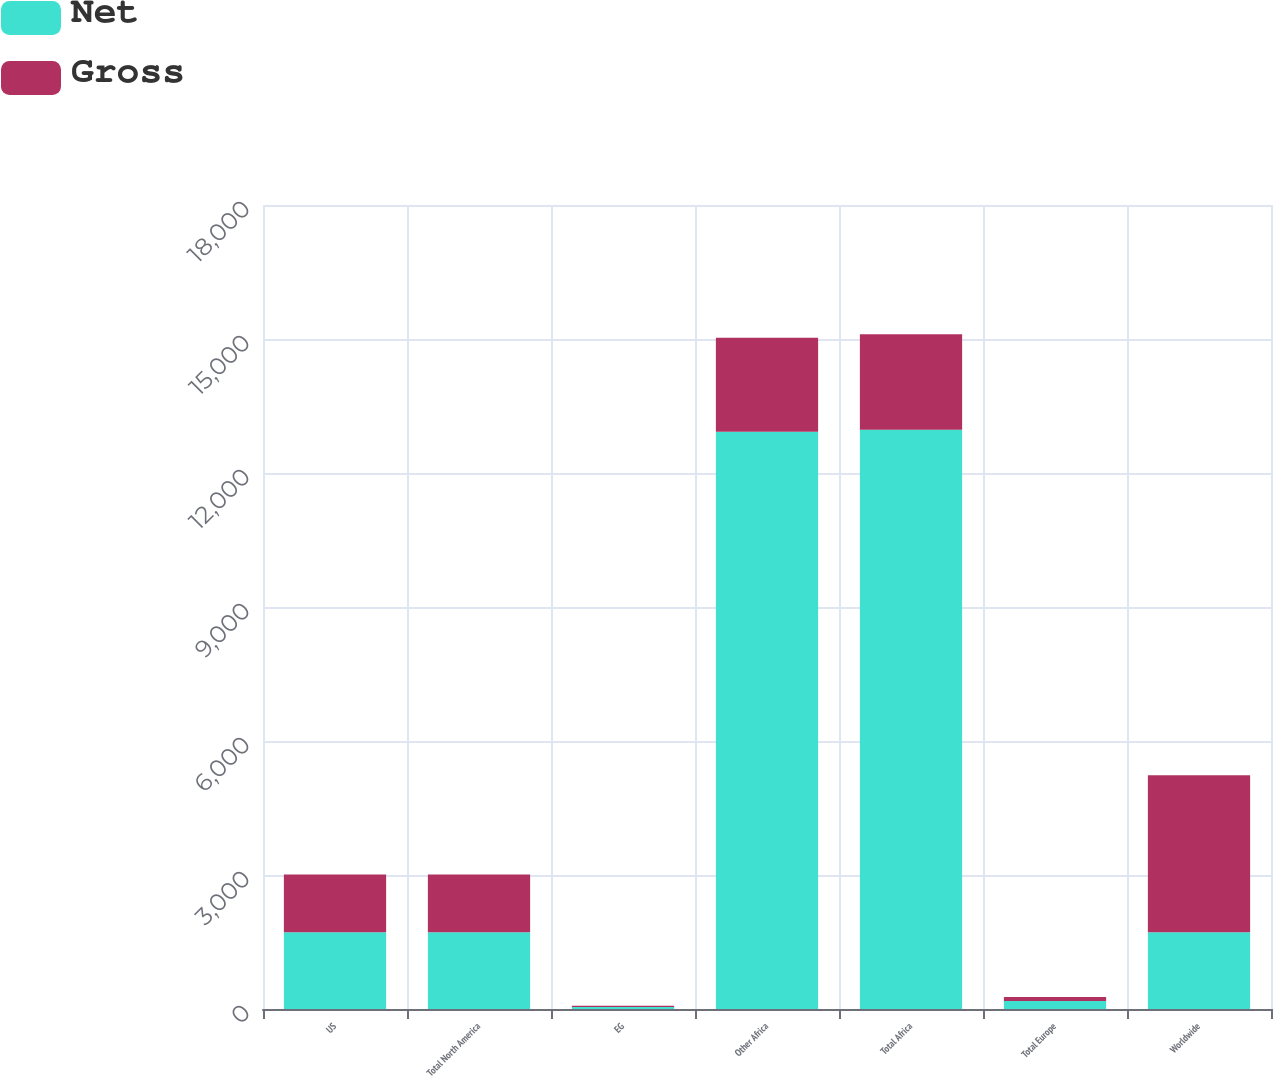<chart> <loc_0><loc_0><loc_500><loc_500><stacked_bar_chart><ecel><fcel>US<fcel>Total North America<fcel>EG<fcel>Other Africa<fcel>Total Africa<fcel>Total Europe<fcel>Worldwide<nl><fcel>Net<fcel>1720<fcel>1720<fcel>45<fcel>12921<fcel>12966<fcel>179<fcel>1720<nl><fcel>Gross<fcel>1289<fcel>1289<fcel>29<fcel>2109<fcel>2138<fcel>88<fcel>3515<nl></chart> 